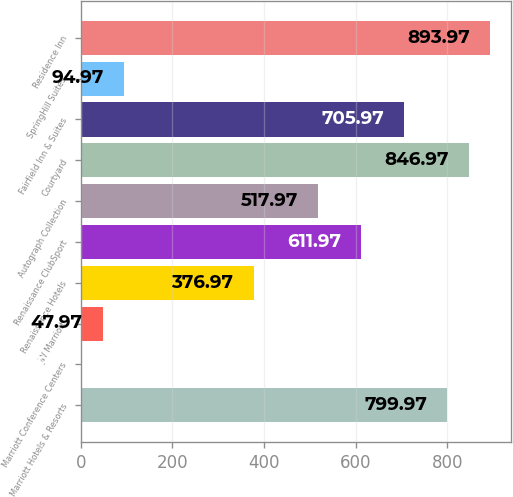<chart> <loc_0><loc_0><loc_500><loc_500><bar_chart><fcel>Marriott Hotels & Resorts<fcel>Marriott Conference Centers<fcel>JW Marriott<fcel>Renaissance Hotels<fcel>Renaissance ClubSport<fcel>Autograph Collection<fcel>Courtyard<fcel>Fairfield Inn & Suites<fcel>SpringHill Suites<fcel>Residence Inn<nl><fcel>799.97<fcel>0.97<fcel>47.97<fcel>376.97<fcel>611.97<fcel>517.97<fcel>846.97<fcel>705.97<fcel>94.97<fcel>893.97<nl></chart> 